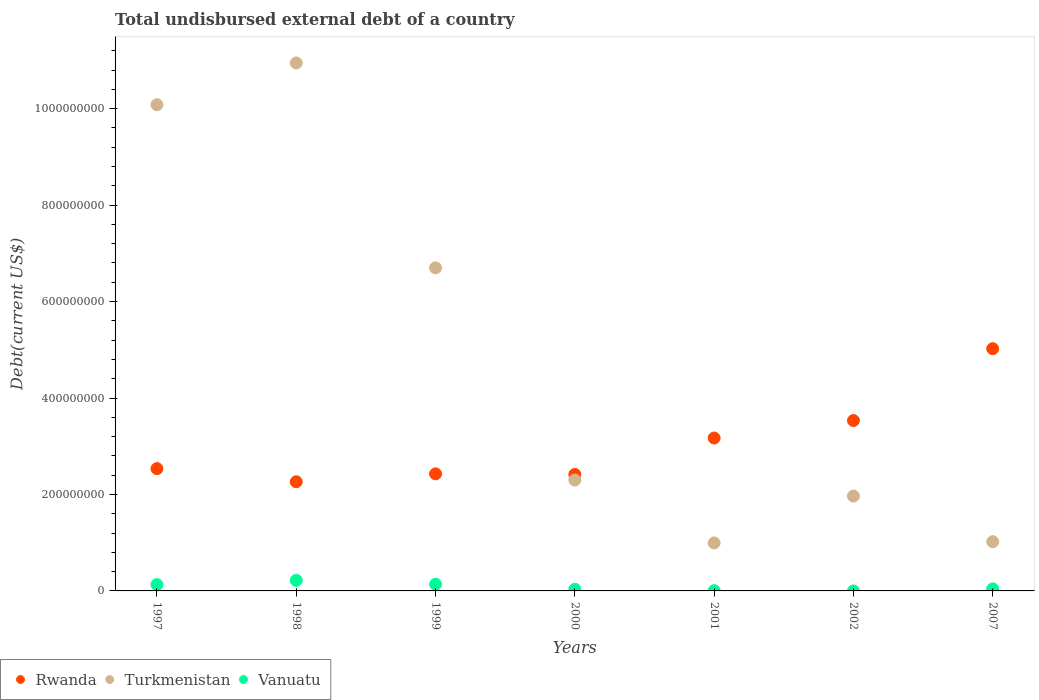How many different coloured dotlines are there?
Offer a terse response. 3. Is the number of dotlines equal to the number of legend labels?
Make the answer very short. Yes. What is the total undisbursed external debt in Rwanda in 2000?
Ensure brevity in your answer.  2.42e+08. Across all years, what is the maximum total undisbursed external debt in Turkmenistan?
Provide a short and direct response. 1.09e+09. Across all years, what is the minimum total undisbursed external debt in Vanuatu?
Your response must be concise. 1.20e+04. In which year was the total undisbursed external debt in Turkmenistan maximum?
Keep it short and to the point. 1998. What is the total total undisbursed external debt in Turkmenistan in the graph?
Provide a succinct answer. 3.40e+09. What is the difference between the total undisbursed external debt in Rwanda in 2000 and that in 2001?
Provide a succinct answer. -7.55e+07. What is the difference between the total undisbursed external debt in Rwanda in 1997 and the total undisbursed external debt in Turkmenistan in 1999?
Your response must be concise. -4.16e+08. What is the average total undisbursed external debt in Vanuatu per year?
Offer a terse response. 8.14e+06. In the year 2000, what is the difference between the total undisbursed external debt in Turkmenistan and total undisbursed external debt in Vanuatu?
Provide a short and direct response. 2.27e+08. What is the ratio of the total undisbursed external debt in Vanuatu in 1999 to that in 2000?
Provide a succinct answer. 4.06. Is the difference between the total undisbursed external debt in Turkmenistan in 1997 and 1998 greater than the difference between the total undisbursed external debt in Vanuatu in 1997 and 1998?
Provide a short and direct response. No. What is the difference between the highest and the second highest total undisbursed external debt in Rwanda?
Make the answer very short. 1.49e+08. What is the difference between the highest and the lowest total undisbursed external debt in Vanuatu?
Offer a very short reply. 2.20e+07. In how many years, is the total undisbursed external debt in Rwanda greater than the average total undisbursed external debt in Rwanda taken over all years?
Make the answer very short. 3. Is the sum of the total undisbursed external debt in Rwanda in 1999 and 2000 greater than the maximum total undisbursed external debt in Vanuatu across all years?
Make the answer very short. Yes. Is it the case that in every year, the sum of the total undisbursed external debt in Rwanda and total undisbursed external debt in Vanuatu  is greater than the total undisbursed external debt in Turkmenistan?
Provide a short and direct response. No. Is the total undisbursed external debt in Rwanda strictly greater than the total undisbursed external debt in Turkmenistan over the years?
Keep it short and to the point. No. How many dotlines are there?
Your answer should be compact. 3. How many years are there in the graph?
Give a very brief answer. 7. What is the difference between two consecutive major ticks on the Y-axis?
Offer a very short reply. 2.00e+08. Are the values on the major ticks of Y-axis written in scientific E-notation?
Make the answer very short. No. Does the graph contain any zero values?
Provide a succinct answer. No. What is the title of the graph?
Keep it short and to the point. Total undisbursed external debt of a country. What is the label or title of the X-axis?
Provide a short and direct response. Years. What is the label or title of the Y-axis?
Your answer should be compact. Debt(current US$). What is the Debt(current US$) of Rwanda in 1997?
Give a very brief answer. 2.54e+08. What is the Debt(current US$) of Turkmenistan in 1997?
Offer a very short reply. 1.01e+09. What is the Debt(current US$) of Vanuatu in 1997?
Give a very brief answer. 1.31e+07. What is the Debt(current US$) in Rwanda in 1998?
Offer a very short reply. 2.26e+08. What is the Debt(current US$) of Turkmenistan in 1998?
Your answer should be compact. 1.09e+09. What is the Debt(current US$) in Vanuatu in 1998?
Give a very brief answer. 2.20e+07. What is the Debt(current US$) in Rwanda in 1999?
Give a very brief answer. 2.43e+08. What is the Debt(current US$) of Turkmenistan in 1999?
Offer a terse response. 6.70e+08. What is the Debt(current US$) in Vanuatu in 1999?
Your answer should be very brief. 1.38e+07. What is the Debt(current US$) of Rwanda in 2000?
Your answer should be compact. 2.42e+08. What is the Debt(current US$) in Turkmenistan in 2000?
Keep it short and to the point. 2.30e+08. What is the Debt(current US$) of Vanuatu in 2000?
Offer a terse response. 3.39e+06. What is the Debt(current US$) of Rwanda in 2001?
Offer a very short reply. 3.17e+08. What is the Debt(current US$) in Turkmenistan in 2001?
Provide a short and direct response. 9.95e+07. What is the Debt(current US$) of Vanuatu in 2001?
Make the answer very short. 5.09e+05. What is the Debt(current US$) in Rwanda in 2002?
Your answer should be very brief. 3.53e+08. What is the Debt(current US$) in Turkmenistan in 2002?
Provide a short and direct response. 1.97e+08. What is the Debt(current US$) of Vanuatu in 2002?
Make the answer very short. 1.20e+04. What is the Debt(current US$) in Rwanda in 2007?
Your answer should be very brief. 5.02e+08. What is the Debt(current US$) of Turkmenistan in 2007?
Keep it short and to the point. 1.02e+08. What is the Debt(current US$) of Vanuatu in 2007?
Provide a short and direct response. 4.20e+06. Across all years, what is the maximum Debt(current US$) in Rwanda?
Give a very brief answer. 5.02e+08. Across all years, what is the maximum Debt(current US$) in Turkmenistan?
Make the answer very short. 1.09e+09. Across all years, what is the maximum Debt(current US$) of Vanuatu?
Your answer should be very brief. 2.20e+07. Across all years, what is the minimum Debt(current US$) in Rwanda?
Give a very brief answer. 2.26e+08. Across all years, what is the minimum Debt(current US$) of Turkmenistan?
Your response must be concise. 9.95e+07. Across all years, what is the minimum Debt(current US$) in Vanuatu?
Make the answer very short. 1.20e+04. What is the total Debt(current US$) of Rwanda in the graph?
Your response must be concise. 2.14e+09. What is the total Debt(current US$) of Turkmenistan in the graph?
Ensure brevity in your answer.  3.40e+09. What is the total Debt(current US$) of Vanuatu in the graph?
Give a very brief answer. 5.70e+07. What is the difference between the Debt(current US$) in Rwanda in 1997 and that in 1998?
Offer a very short reply. 2.73e+07. What is the difference between the Debt(current US$) in Turkmenistan in 1997 and that in 1998?
Give a very brief answer. -8.66e+07. What is the difference between the Debt(current US$) in Vanuatu in 1997 and that in 1998?
Provide a succinct answer. -8.90e+06. What is the difference between the Debt(current US$) in Rwanda in 1997 and that in 1999?
Make the answer very short. 1.09e+07. What is the difference between the Debt(current US$) of Turkmenistan in 1997 and that in 1999?
Provide a succinct answer. 3.38e+08. What is the difference between the Debt(current US$) in Vanuatu in 1997 and that in 1999?
Keep it short and to the point. -6.90e+05. What is the difference between the Debt(current US$) of Rwanda in 1997 and that in 2000?
Offer a very short reply. 1.20e+07. What is the difference between the Debt(current US$) of Turkmenistan in 1997 and that in 2000?
Offer a very short reply. 7.78e+08. What is the difference between the Debt(current US$) in Vanuatu in 1997 and that in 2000?
Make the answer very short. 9.70e+06. What is the difference between the Debt(current US$) in Rwanda in 1997 and that in 2001?
Your response must be concise. -6.35e+07. What is the difference between the Debt(current US$) of Turkmenistan in 1997 and that in 2001?
Provide a short and direct response. 9.09e+08. What is the difference between the Debt(current US$) in Vanuatu in 1997 and that in 2001?
Your response must be concise. 1.26e+07. What is the difference between the Debt(current US$) in Rwanda in 1997 and that in 2002?
Your response must be concise. -9.96e+07. What is the difference between the Debt(current US$) in Turkmenistan in 1997 and that in 2002?
Offer a very short reply. 8.12e+08. What is the difference between the Debt(current US$) in Vanuatu in 1997 and that in 2002?
Offer a very short reply. 1.31e+07. What is the difference between the Debt(current US$) of Rwanda in 1997 and that in 2007?
Provide a short and direct response. -2.49e+08. What is the difference between the Debt(current US$) of Turkmenistan in 1997 and that in 2007?
Your response must be concise. 9.06e+08. What is the difference between the Debt(current US$) in Vanuatu in 1997 and that in 2007?
Offer a very short reply. 8.89e+06. What is the difference between the Debt(current US$) of Rwanda in 1998 and that in 1999?
Offer a very short reply. -1.64e+07. What is the difference between the Debt(current US$) in Turkmenistan in 1998 and that in 1999?
Your response must be concise. 4.25e+08. What is the difference between the Debt(current US$) in Vanuatu in 1998 and that in 1999?
Give a very brief answer. 8.21e+06. What is the difference between the Debt(current US$) in Rwanda in 1998 and that in 2000?
Your response must be concise. -1.52e+07. What is the difference between the Debt(current US$) of Turkmenistan in 1998 and that in 2000?
Provide a succinct answer. 8.65e+08. What is the difference between the Debt(current US$) of Vanuatu in 1998 and that in 2000?
Keep it short and to the point. 1.86e+07. What is the difference between the Debt(current US$) in Rwanda in 1998 and that in 2001?
Ensure brevity in your answer.  -9.07e+07. What is the difference between the Debt(current US$) of Turkmenistan in 1998 and that in 2001?
Make the answer very short. 9.95e+08. What is the difference between the Debt(current US$) of Vanuatu in 1998 and that in 2001?
Make the answer very short. 2.15e+07. What is the difference between the Debt(current US$) of Rwanda in 1998 and that in 2002?
Your answer should be very brief. -1.27e+08. What is the difference between the Debt(current US$) in Turkmenistan in 1998 and that in 2002?
Keep it short and to the point. 8.98e+08. What is the difference between the Debt(current US$) in Vanuatu in 1998 and that in 2002?
Provide a short and direct response. 2.20e+07. What is the difference between the Debt(current US$) in Rwanda in 1998 and that in 2007?
Provide a succinct answer. -2.76e+08. What is the difference between the Debt(current US$) of Turkmenistan in 1998 and that in 2007?
Provide a succinct answer. 9.93e+08. What is the difference between the Debt(current US$) in Vanuatu in 1998 and that in 2007?
Ensure brevity in your answer.  1.78e+07. What is the difference between the Debt(current US$) in Rwanda in 1999 and that in 2000?
Provide a short and direct response. 1.11e+06. What is the difference between the Debt(current US$) of Turkmenistan in 1999 and that in 2000?
Make the answer very short. 4.40e+08. What is the difference between the Debt(current US$) of Vanuatu in 1999 and that in 2000?
Give a very brief answer. 1.04e+07. What is the difference between the Debt(current US$) in Rwanda in 1999 and that in 2001?
Provide a short and direct response. -7.43e+07. What is the difference between the Debt(current US$) in Turkmenistan in 1999 and that in 2001?
Make the answer very short. 5.70e+08. What is the difference between the Debt(current US$) of Vanuatu in 1999 and that in 2001?
Your response must be concise. 1.33e+07. What is the difference between the Debt(current US$) in Rwanda in 1999 and that in 2002?
Ensure brevity in your answer.  -1.11e+08. What is the difference between the Debt(current US$) in Turkmenistan in 1999 and that in 2002?
Keep it short and to the point. 4.73e+08. What is the difference between the Debt(current US$) of Vanuatu in 1999 and that in 2002?
Keep it short and to the point. 1.38e+07. What is the difference between the Debt(current US$) in Rwanda in 1999 and that in 2007?
Provide a succinct answer. -2.60e+08. What is the difference between the Debt(current US$) of Turkmenistan in 1999 and that in 2007?
Make the answer very short. 5.68e+08. What is the difference between the Debt(current US$) in Vanuatu in 1999 and that in 2007?
Offer a very short reply. 9.58e+06. What is the difference between the Debt(current US$) of Rwanda in 2000 and that in 2001?
Your answer should be very brief. -7.55e+07. What is the difference between the Debt(current US$) of Turkmenistan in 2000 and that in 2001?
Make the answer very short. 1.30e+08. What is the difference between the Debt(current US$) in Vanuatu in 2000 and that in 2001?
Provide a succinct answer. 2.88e+06. What is the difference between the Debt(current US$) of Rwanda in 2000 and that in 2002?
Provide a succinct answer. -1.12e+08. What is the difference between the Debt(current US$) of Turkmenistan in 2000 and that in 2002?
Ensure brevity in your answer.  3.32e+07. What is the difference between the Debt(current US$) in Vanuatu in 2000 and that in 2002?
Give a very brief answer. 3.38e+06. What is the difference between the Debt(current US$) of Rwanda in 2000 and that in 2007?
Provide a succinct answer. -2.61e+08. What is the difference between the Debt(current US$) in Turkmenistan in 2000 and that in 2007?
Provide a short and direct response. 1.28e+08. What is the difference between the Debt(current US$) in Vanuatu in 2000 and that in 2007?
Offer a very short reply. -8.07e+05. What is the difference between the Debt(current US$) of Rwanda in 2001 and that in 2002?
Your answer should be compact. -3.62e+07. What is the difference between the Debt(current US$) in Turkmenistan in 2001 and that in 2002?
Your answer should be very brief. -9.72e+07. What is the difference between the Debt(current US$) of Vanuatu in 2001 and that in 2002?
Offer a very short reply. 4.97e+05. What is the difference between the Debt(current US$) of Rwanda in 2001 and that in 2007?
Provide a succinct answer. -1.85e+08. What is the difference between the Debt(current US$) in Turkmenistan in 2001 and that in 2007?
Your answer should be compact. -2.60e+06. What is the difference between the Debt(current US$) of Vanuatu in 2001 and that in 2007?
Provide a short and direct response. -3.69e+06. What is the difference between the Debt(current US$) of Rwanda in 2002 and that in 2007?
Your answer should be compact. -1.49e+08. What is the difference between the Debt(current US$) of Turkmenistan in 2002 and that in 2007?
Keep it short and to the point. 9.46e+07. What is the difference between the Debt(current US$) of Vanuatu in 2002 and that in 2007?
Your answer should be compact. -4.19e+06. What is the difference between the Debt(current US$) in Rwanda in 1997 and the Debt(current US$) in Turkmenistan in 1998?
Give a very brief answer. -8.41e+08. What is the difference between the Debt(current US$) of Rwanda in 1997 and the Debt(current US$) of Vanuatu in 1998?
Offer a very short reply. 2.32e+08. What is the difference between the Debt(current US$) in Turkmenistan in 1997 and the Debt(current US$) in Vanuatu in 1998?
Your answer should be very brief. 9.86e+08. What is the difference between the Debt(current US$) of Rwanda in 1997 and the Debt(current US$) of Turkmenistan in 1999?
Keep it short and to the point. -4.16e+08. What is the difference between the Debt(current US$) in Rwanda in 1997 and the Debt(current US$) in Vanuatu in 1999?
Offer a terse response. 2.40e+08. What is the difference between the Debt(current US$) in Turkmenistan in 1997 and the Debt(current US$) in Vanuatu in 1999?
Offer a very short reply. 9.94e+08. What is the difference between the Debt(current US$) of Rwanda in 1997 and the Debt(current US$) of Turkmenistan in 2000?
Provide a succinct answer. 2.37e+07. What is the difference between the Debt(current US$) in Rwanda in 1997 and the Debt(current US$) in Vanuatu in 2000?
Your answer should be very brief. 2.50e+08. What is the difference between the Debt(current US$) in Turkmenistan in 1997 and the Debt(current US$) in Vanuatu in 2000?
Make the answer very short. 1.00e+09. What is the difference between the Debt(current US$) in Rwanda in 1997 and the Debt(current US$) in Turkmenistan in 2001?
Offer a very short reply. 1.54e+08. What is the difference between the Debt(current US$) in Rwanda in 1997 and the Debt(current US$) in Vanuatu in 2001?
Your answer should be compact. 2.53e+08. What is the difference between the Debt(current US$) in Turkmenistan in 1997 and the Debt(current US$) in Vanuatu in 2001?
Make the answer very short. 1.01e+09. What is the difference between the Debt(current US$) of Rwanda in 1997 and the Debt(current US$) of Turkmenistan in 2002?
Make the answer very short. 5.69e+07. What is the difference between the Debt(current US$) of Rwanda in 1997 and the Debt(current US$) of Vanuatu in 2002?
Provide a short and direct response. 2.54e+08. What is the difference between the Debt(current US$) of Turkmenistan in 1997 and the Debt(current US$) of Vanuatu in 2002?
Ensure brevity in your answer.  1.01e+09. What is the difference between the Debt(current US$) in Rwanda in 1997 and the Debt(current US$) in Turkmenistan in 2007?
Give a very brief answer. 1.52e+08. What is the difference between the Debt(current US$) of Rwanda in 1997 and the Debt(current US$) of Vanuatu in 2007?
Offer a very short reply. 2.49e+08. What is the difference between the Debt(current US$) in Turkmenistan in 1997 and the Debt(current US$) in Vanuatu in 2007?
Your answer should be compact. 1.00e+09. What is the difference between the Debt(current US$) in Rwanda in 1998 and the Debt(current US$) in Turkmenistan in 1999?
Give a very brief answer. -4.44e+08. What is the difference between the Debt(current US$) in Rwanda in 1998 and the Debt(current US$) in Vanuatu in 1999?
Your answer should be very brief. 2.13e+08. What is the difference between the Debt(current US$) of Turkmenistan in 1998 and the Debt(current US$) of Vanuatu in 1999?
Make the answer very short. 1.08e+09. What is the difference between the Debt(current US$) of Rwanda in 1998 and the Debt(current US$) of Turkmenistan in 2000?
Offer a terse response. -3.54e+06. What is the difference between the Debt(current US$) of Rwanda in 1998 and the Debt(current US$) of Vanuatu in 2000?
Give a very brief answer. 2.23e+08. What is the difference between the Debt(current US$) in Turkmenistan in 1998 and the Debt(current US$) in Vanuatu in 2000?
Make the answer very short. 1.09e+09. What is the difference between the Debt(current US$) in Rwanda in 1998 and the Debt(current US$) in Turkmenistan in 2001?
Your response must be concise. 1.27e+08. What is the difference between the Debt(current US$) in Rwanda in 1998 and the Debt(current US$) in Vanuatu in 2001?
Offer a terse response. 2.26e+08. What is the difference between the Debt(current US$) in Turkmenistan in 1998 and the Debt(current US$) in Vanuatu in 2001?
Your answer should be very brief. 1.09e+09. What is the difference between the Debt(current US$) in Rwanda in 1998 and the Debt(current US$) in Turkmenistan in 2002?
Offer a very short reply. 2.97e+07. What is the difference between the Debt(current US$) in Rwanda in 1998 and the Debt(current US$) in Vanuatu in 2002?
Offer a very short reply. 2.26e+08. What is the difference between the Debt(current US$) of Turkmenistan in 1998 and the Debt(current US$) of Vanuatu in 2002?
Keep it short and to the point. 1.09e+09. What is the difference between the Debt(current US$) of Rwanda in 1998 and the Debt(current US$) of Turkmenistan in 2007?
Give a very brief answer. 1.24e+08. What is the difference between the Debt(current US$) of Rwanda in 1998 and the Debt(current US$) of Vanuatu in 2007?
Ensure brevity in your answer.  2.22e+08. What is the difference between the Debt(current US$) in Turkmenistan in 1998 and the Debt(current US$) in Vanuatu in 2007?
Offer a very short reply. 1.09e+09. What is the difference between the Debt(current US$) of Rwanda in 1999 and the Debt(current US$) of Turkmenistan in 2000?
Your answer should be compact. 1.28e+07. What is the difference between the Debt(current US$) in Rwanda in 1999 and the Debt(current US$) in Vanuatu in 2000?
Your answer should be very brief. 2.39e+08. What is the difference between the Debt(current US$) in Turkmenistan in 1999 and the Debt(current US$) in Vanuatu in 2000?
Your response must be concise. 6.67e+08. What is the difference between the Debt(current US$) of Rwanda in 1999 and the Debt(current US$) of Turkmenistan in 2001?
Provide a short and direct response. 1.43e+08. What is the difference between the Debt(current US$) of Rwanda in 1999 and the Debt(current US$) of Vanuatu in 2001?
Keep it short and to the point. 2.42e+08. What is the difference between the Debt(current US$) of Turkmenistan in 1999 and the Debt(current US$) of Vanuatu in 2001?
Provide a succinct answer. 6.69e+08. What is the difference between the Debt(current US$) of Rwanda in 1999 and the Debt(current US$) of Turkmenistan in 2002?
Provide a short and direct response. 4.60e+07. What is the difference between the Debt(current US$) of Rwanda in 1999 and the Debt(current US$) of Vanuatu in 2002?
Offer a very short reply. 2.43e+08. What is the difference between the Debt(current US$) of Turkmenistan in 1999 and the Debt(current US$) of Vanuatu in 2002?
Give a very brief answer. 6.70e+08. What is the difference between the Debt(current US$) of Rwanda in 1999 and the Debt(current US$) of Turkmenistan in 2007?
Make the answer very short. 1.41e+08. What is the difference between the Debt(current US$) in Rwanda in 1999 and the Debt(current US$) in Vanuatu in 2007?
Your answer should be compact. 2.39e+08. What is the difference between the Debt(current US$) in Turkmenistan in 1999 and the Debt(current US$) in Vanuatu in 2007?
Your response must be concise. 6.66e+08. What is the difference between the Debt(current US$) of Rwanda in 2000 and the Debt(current US$) of Turkmenistan in 2001?
Give a very brief answer. 1.42e+08. What is the difference between the Debt(current US$) in Rwanda in 2000 and the Debt(current US$) in Vanuatu in 2001?
Keep it short and to the point. 2.41e+08. What is the difference between the Debt(current US$) in Turkmenistan in 2000 and the Debt(current US$) in Vanuatu in 2001?
Your answer should be compact. 2.29e+08. What is the difference between the Debt(current US$) of Rwanda in 2000 and the Debt(current US$) of Turkmenistan in 2002?
Offer a very short reply. 4.49e+07. What is the difference between the Debt(current US$) of Rwanda in 2000 and the Debt(current US$) of Vanuatu in 2002?
Provide a short and direct response. 2.42e+08. What is the difference between the Debt(current US$) of Turkmenistan in 2000 and the Debt(current US$) of Vanuatu in 2002?
Make the answer very short. 2.30e+08. What is the difference between the Debt(current US$) of Rwanda in 2000 and the Debt(current US$) of Turkmenistan in 2007?
Give a very brief answer. 1.40e+08. What is the difference between the Debt(current US$) in Rwanda in 2000 and the Debt(current US$) in Vanuatu in 2007?
Make the answer very short. 2.37e+08. What is the difference between the Debt(current US$) of Turkmenistan in 2000 and the Debt(current US$) of Vanuatu in 2007?
Your response must be concise. 2.26e+08. What is the difference between the Debt(current US$) of Rwanda in 2001 and the Debt(current US$) of Turkmenistan in 2002?
Ensure brevity in your answer.  1.20e+08. What is the difference between the Debt(current US$) of Rwanda in 2001 and the Debt(current US$) of Vanuatu in 2002?
Offer a very short reply. 3.17e+08. What is the difference between the Debt(current US$) of Turkmenistan in 2001 and the Debt(current US$) of Vanuatu in 2002?
Your answer should be very brief. 9.95e+07. What is the difference between the Debt(current US$) of Rwanda in 2001 and the Debt(current US$) of Turkmenistan in 2007?
Your answer should be compact. 2.15e+08. What is the difference between the Debt(current US$) in Rwanda in 2001 and the Debt(current US$) in Vanuatu in 2007?
Offer a very short reply. 3.13e+08. What is the difference between the Debt(current US$) in Turkmenistan in 2001 and the Debt(current US$) in Vanuatu in 2007?
Keep it short and to the point. 9.53e+07. What is the difference between the Debt(current US$) of Rwanda in 2002 and the Debt(current US$) of Turkmenistan in 2007?
Offer a terse response. 2.51e+08. What is the difference between the Debt(current US$) in Rwanda in 2002 and the Debt(current US$) in Vanuatu in 2007?
Keep it short and to the point. 3.49e+08. What is the difference between the Debt(current US$) in Turkmenistan in 2002 and the Debt(current US$) in Vanuatu in 2007?
Keep it short and to the point. 1.92e+08. What is the average Debt(current US$) of Rwanda per year?
Offer a very short reply. 3.05e+08. What is the average Debt(current US$) of Turkmenistan per year?
Give a very brief answer. 4.86e+08. What is the average Debt(current US$) in Vanuatu per year?
Provide a short and direct response. 8.14e+06. In the year 1997, what is the difference between the Debt(current US$) in Rwanda and Debt(current US$) in Turkmenistan?
Your response must be concise. -7.55e+08. In the year 1997, what is the difference between the Debt(current US$) of Rwanda and Debt(current US$) of Vanuatu?
Ensure brevity in your answer.  2.41e+08. In the year 1997, what is the difference between the Debt(current US$) in Turkmenistan and Debt(current US$) in Vanuatu?
Offer a terse response. 9.95e+08. In the year 1998, what is the difference between the Debt(current US$) in Rwanda and Debt(current US$) in Turkmenistan?
Make the answer very short. -8.68e+08. In the year 1998, what is the difference between the Debt(current US$) in Rwanda and Debt(current US$) in Vanuatu?
Ensure brevity in your answer.  2.04e+08. In the year 1998, what is the difference between the Debt(current US$) in Turkmenistan and Debt(current US$) in Vanuatu?
Give a very brief answer. 1.07e+09. In the year 1999, what is the difference between the Debt(current US$) of Rwanda and Debt(current US$) of Turkmenistan?
Ensure brevity in your answer.  -4.27e+08. In the year 1999, what is the difference between the Debt(current US$) of Rwanda and Debt(current US$) of Vanuatu?
Offer a terse response. 2.29e+08. In the year 1999, what is the difference between the Debt(current US$) of Turkmenistan and Debt(current US$) of Vanuatu?
Offer a very short reply. 6.56e+08. In the year 2000, what is the difference between the Debt(current US$) of Rwanda and Debt(current US$) of Turkmenistan?
Keep it short and to the point. 1.17e+07. In the year 2000, what is the difference between the Debt(current US$) of Rwanda and Debt(current US$) of Vanuatu?
Make the answer very short. 2.38e+08. In the year 2000, what is the difference between the Debt(current US$) in Turkmenistan and Debt(current US$) in Vanuatu?
Provide a short and direct response. 2.27e+08. In the year 2001, what is the difference between the Debt(current US$) of Rwanda and Debt(current US$) of Turkmenistan?
Your answer should be very brief. 2.18e+08. In the year 2001, what is the difference between the Debt(current US$) in Rwanda and Debt(current US$) in Vanuatu?
Your response must be concise. 3.17e+08. In the year 2001, what is the difference between the Debt(current US$) in Turkmenistan and Debt(current US$) in Vanuatu?
Ensure brevity in your answer.  9.90e+07. In the year 2002, what is the difference between the Debt(current US$) of Rwanda and Debt(current US$) of Turkmenistan?
Provide a short and direct response. 1.57e+08. In the year 2002, what is the difference between the Debt(current US$) of Rwanda and Debt(current US$) of Vanuatu?
Offer a very short reply. 3.53e+08. In the year 2002, what is the difference between the Debt(current US$) of Turkmenistan and Debt(current US$) of Vanuatu?
Ensure brevity in your answer.  1.97e+08. In the year 2007, what is the difference between the Debt(current US$) of Rwanda and Debt(current US$) of Turkmenistan?
Provide a succinct answer. 4.00e+08. In the year 2007, what is the difference between the Debt(current US$) in Rwanda and Debt(current US$) in Vanuatu?
Offer a very short reply. 4.98e+08. In the year 2007, what is the difference between the Debt(current US$) in Turkmenistan and Debt(current US$) in Vanuatu?
Offer a terse response. 9.79e+07. What is the ratio of the Debt(current US$) in Rwanda in 1997 to that in 1998?
Provide a succinct answer. 1.12. What is the ratio of the Debt(current US$) of Turkmenistan in 1997 to that in 1998?
Keep it short and to the point. 0.92. What is the ratio of the Debt(current US$) of Vanuatu in 1997 to that in 1998?
Keep it short and to the point. 0.6. What is the ratio of the Debt(current US$) of Rwanda in 1997 to that in 1999?
Provide a succinct answer. 1.04. What is the ratio of the Debt(current US$) of Turkmenistan in 1997 to that in 1999?
Make the answer very short. 1.5. What is the ratio of the Debt(current US$) of Vanuatu in 1997 to that in 1999?
Your response must be concise. 0.95. What is the ratio of the Debt(current US$) of Rwanda in 1997 to that in 2000?
Offer a terse response. 1.05. What is the ratio of the Debt(current US$) in Turkmenistan in 1997 to that in 2000?
Make the answer very short. 4.39. What is the ratio of the Debt(current US$) of Vanuatu in 1997 to that in 2000?
Offer a very short reply. 3.86. What is the ratio of the Debt(current US$) in Rwanda in 1997 to that in 2001?
Provide a succinct answer. 0.8. What is the ratio of the Debt(current US$) in Turkmenistan in 1997 to that in 2001?
Ensure brevity in your answer.  10.13. What is the ratio of the Debt(current US$) in Vanuatu in 1997 to that in 2001?
Keep it short and to the point. 25.71. What is the ratio of the Debt(current US$) of Rwanda in 1997 to that in 2002?
Keep it short and to the point. 0.72. What is the ratio of the Debt(current US$) in Turkmenistan in 1997 to that in 2002?
Provide a short and direct response. 5.13. What is the ratio of the Debt(current US$) in Vanuatu in 1997 to that in 2002?
Offer a very short reply. 1090.67. What is the ratio of the Debt(current US$) in Rwanda in 1997 to that in 2007?
Your answer should be very brief. 0.5. What is the ratio of the Debt(current US$) of Turkmenistan in 1997 to that in 2007?
Make the answer very short. 9.87. What is the ratio of the Debt(current US$) of Vanuatu in 1997 to that in 2007?
Your answer should be very brief. 3.12. What is the ratio of the Debt(current US$) of Rwanda in 1998 to that in 1999?
Your answer should be very brief. 0.93. What is the ratio of the Debt(current US$) of Turkmenistan in 1998 to that in 1999?
Offer a terse response. 1.63. What is the ratio of the Debt(current US$) of Vanuatu in 1998 to that in 1999?
Ensure brevity in your answer.  1.6. What is the ratio of the Debt(current US$) in Rwanda in 1998 to that in 2000?
Keep it short and to the point. 0.94. What is the ratio of the Debt(current US$) of Turkmenistan in 1998 to that in 2000?
Make the answer very short. 4.76. What is the ratio of the Debt(current US$) of Vanuatu in 1998 to that in 2000?
Keep it short and to the point. 6.48. What is the ratio of the Debt(current US$) of Rwanda in 1998 to that in 2001?
Your response must be concise. 0.71. What is the ratio of the Debt(current US$) of Turkmenistan in 1998 to that in 2001?
Your response must be concise. 11. What is the ratio of the Debt(current US$) in Vanuatu in 1998 to that in 2001?
Your response must be concise. 43.2. What is the ratio of the Debt(current US$) of Rwanda in 1998 to that in 2002?
Your answer should be compact. 0.64. What is the ratio of the Debt(current US$) in Turkmenistan in 1998 to that in 2002?
Your response must be concise. 5.57. What is the ratio of the Debt(current US$) in Vanuatu in 1998 to that in 2002?
Your answer should be compact. 1832.5. What is the ratio of the Debt(current US$) of Rwanda in 1998 to that in 2007?
Keep it short and to the point. 0.45. What is the ratio of the Debt(current US$) in Turkmenistan in 1998 to that in 2007?
Your response must be concise. 10.72. What is the ratio of the Debt(current US$) of Vanuatu in 1998 to that in 2007?
Ensure brevity in your answer.  5.24. What is the ratio of the Debt(current US$) of Turkmenistan in 1999 to that in 2000?
Provide a succinct answer. 2.91. What is the ratio of the Debt(current US$) in Vanuatu in 1999 to that in 2000?
Provide a short and direct response. 4.06. What is the ratio of the Debt(current US$) in Rwanda in 1999 to that in 2001?
Provide a short and direct response. 0.77. What is the ratio of the Debt(current US$) of Turkmenistan in 1999 to that in 2001?
Your response must be concise. 6.73. What is the ratio of the Debt(current US$) in Vanuatu in 1999 to that in 2001?
Your response must be concise. 27.07. What is the ratio of the Debt(current US$) of Rwanda in 1999 to that in 2002?
Provide a short and direct response. 0.69. What is the ratio of the Debt(current US$) of Turkmenistan in 1999 to that in 2002?
Your answer should be very brief. 3.41. What is the ratio of the Debt(current US$) of Vanuatu in 1999 to that in 2002?
Ensure brevity in your answer.  1148.17. What is the ratio of the Debt(current US$) in Rwanda in 1999 to that in 2007?
Offer a terse response. 0.48. What is the ratio of the Debt(current US$) in Turkmenistan in 1999 to that in 2007?
Ensure brevity in your answer.  6.56. What is the ratio of the Debt(current US$) of Vanuatu in 1999 to that in 2007?
Make the answer very short. 3.28. What is the ratio of the Debt(current US$) of Rwanda in 2000 to that in 2001?
Provide a short and direct response. 0.76. What is the ratio of the Debt(current US$) in Turkmenistan in 2000 to that in 2001?
Give a very brief answer. 2.31. What is the ratio of the Debt(current US$) of Vanuatu in 2000 to that in 2001?
Your answer should be compact. 6.66. What is the ratio of the Debt(current US$) of Rwanda in 2000 to that in 2002?
Provide a succinct answer. 0.68. What is the ratio of the Debt(current US$) of Turkmenistan in 2000 to that in 2002?
Your answer should be compact. 1.17. What is the ratio of the Debt(current US$) of Vanuatu in 2000 to that in 2002?
Offer a terse response. 282.58. What is the ratio of the Debt(current US$) of Rwanda in 2000 to that in 2007?
Offer a very short reply. 0.48. What is the ratio of the Debt(current US$) in Turkmenistan in 2000 to that in 2007?
Give a very brief answer. 2.25. What is the ratio of the Debt(current US$) in Vanuatu in 2000 to that in 2007?
Provide a short and direct response. 0.81. What is the ratio of the Debt(current US$) of Rwanda in 2001 to that in 2002?
Keep it short and to the point. 0.9. What is the ratio of the Debt(current US$) of Turkmenistan in 2001 to that in 2002?
Make the answer very short. 0.51. What is the ratio of the Debt(current US$) of Vanuatu in 2001 to that in 2002?
Your answer should be compact. 42.42. What is the ratio of the Debt(current US$) of Rwanda in 2001 to that in 2007?
Provide a succinct answer. 0.63. What is the ratio of the Debt(current US$) in Turkmenistan in 2001 to that in 2007?
Provide a succinct answer. 0.97. What is the ratio of the Debt(current US$) of Vanuatu in 2001 to that in 2007?
Give a very brief answer. 0.12. What is the ratio of the Debt(current US$) in Rwanda in 2002 to that in 2007?
Provide a succinct answer. 0.7. What is the ratio of the Debt(current US$) in Turkmenistan in 2002 to that in 2007?
Provide a short and direct response. 1.93. What is the ratio of the Debt(current US$) of Vanuatu in 2002 to that in 2007?
Keep it short and to the point. 0. What is the difference between the highest and the second highest Debt(current US$) of Rwanda?
Offer a very short reply. 1.49e+08. What is the difference between the highest and the second highest Debt(current US$) in Turkmenistan?
Provide a short and direct response. 8.66e+07. What is the difference between the highest and the second highest Debt(current US$) in Vanuatu?
Provide a succinct answer. 8.21e+06. What is the difference between the highest and the lowest Debt(current US$) of Rwanda?
Offer a very short reply. 2.76e+08. What is the difference between the highest and the lowest Debt(current US$) of Turkmenistan?
Your answer should be compact. 9.95e+08. What is the difference between the highest and the lowest Debt(current US$) in Vanuatu?
Make the answer very short. 2.20e+07. 